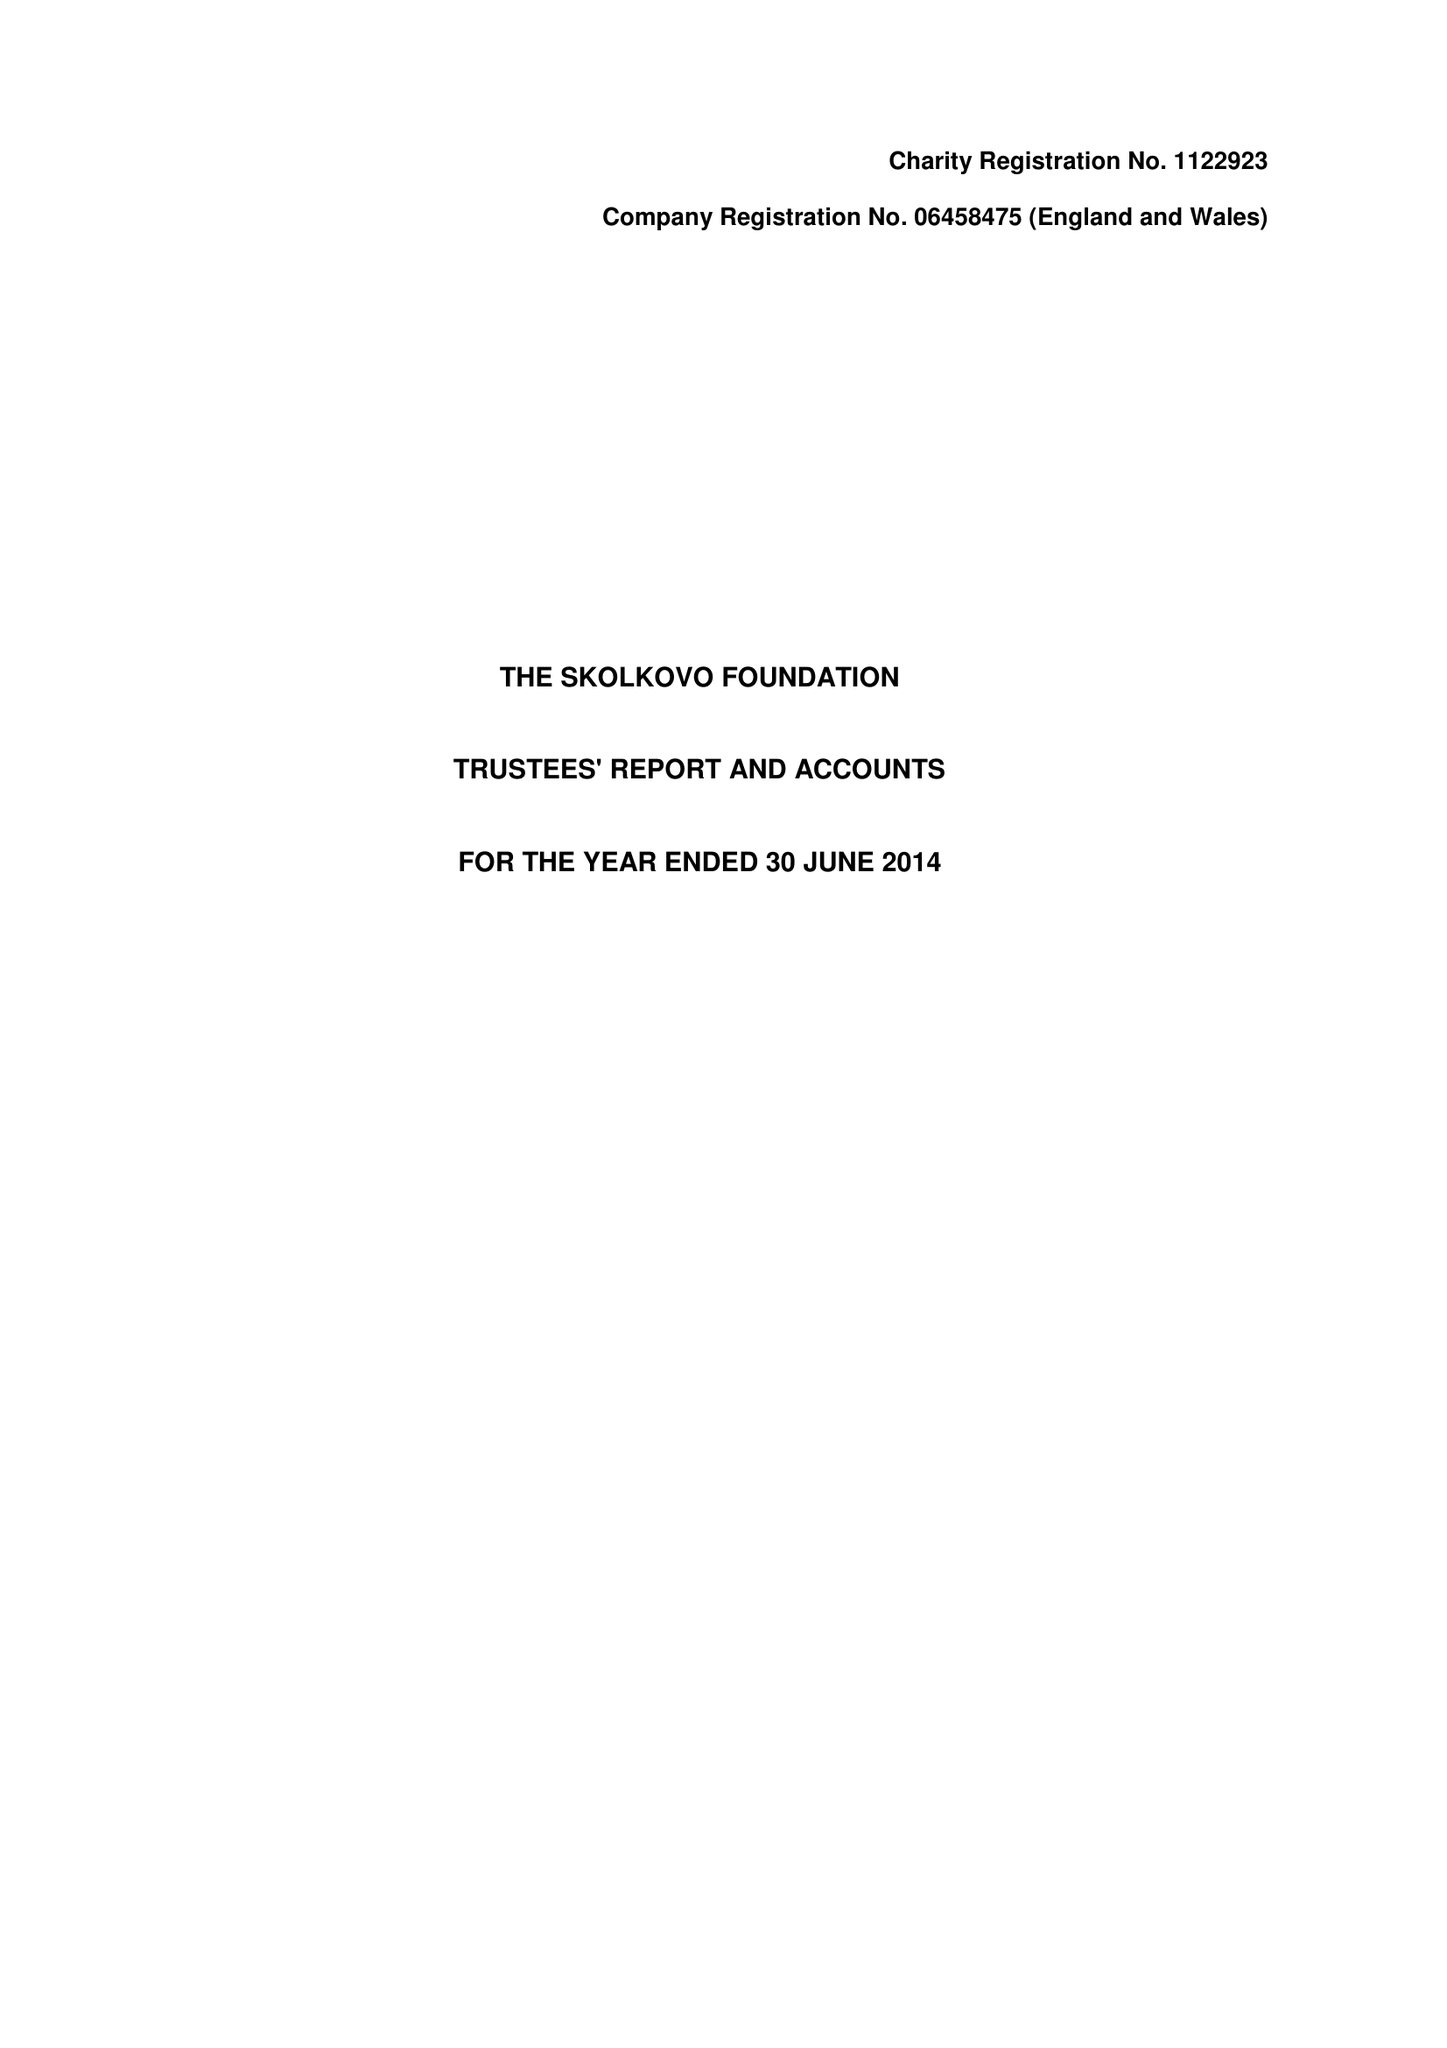What is the value for the spending_annually_in_british_pounds?
Answer the question using a single word or phrase. 641524.00 